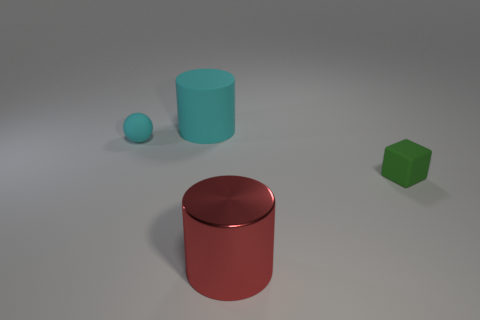Subtract all spheres. How many objects are left? 3 Add 1 small blue metallic balls. How many small blue metallic balls exist? 1 Add 1 small yellow rubber objects. How many objects exist? 5 Subtract 0 green spheres. How many objects are left? 4 Subtract 1 cubes. How many cubes are left? 0 Subtract all blue blocks. Subtract all cyan cylinders. How many blocks are left? 1 Subtract all blue blocks. How many blue spheres are left? 0 Subtract all small brown rubber objects. Subtract all big red shiny objects. How many objects are left? 3 Add 4 small cubes. How many small cubes are left? 5 